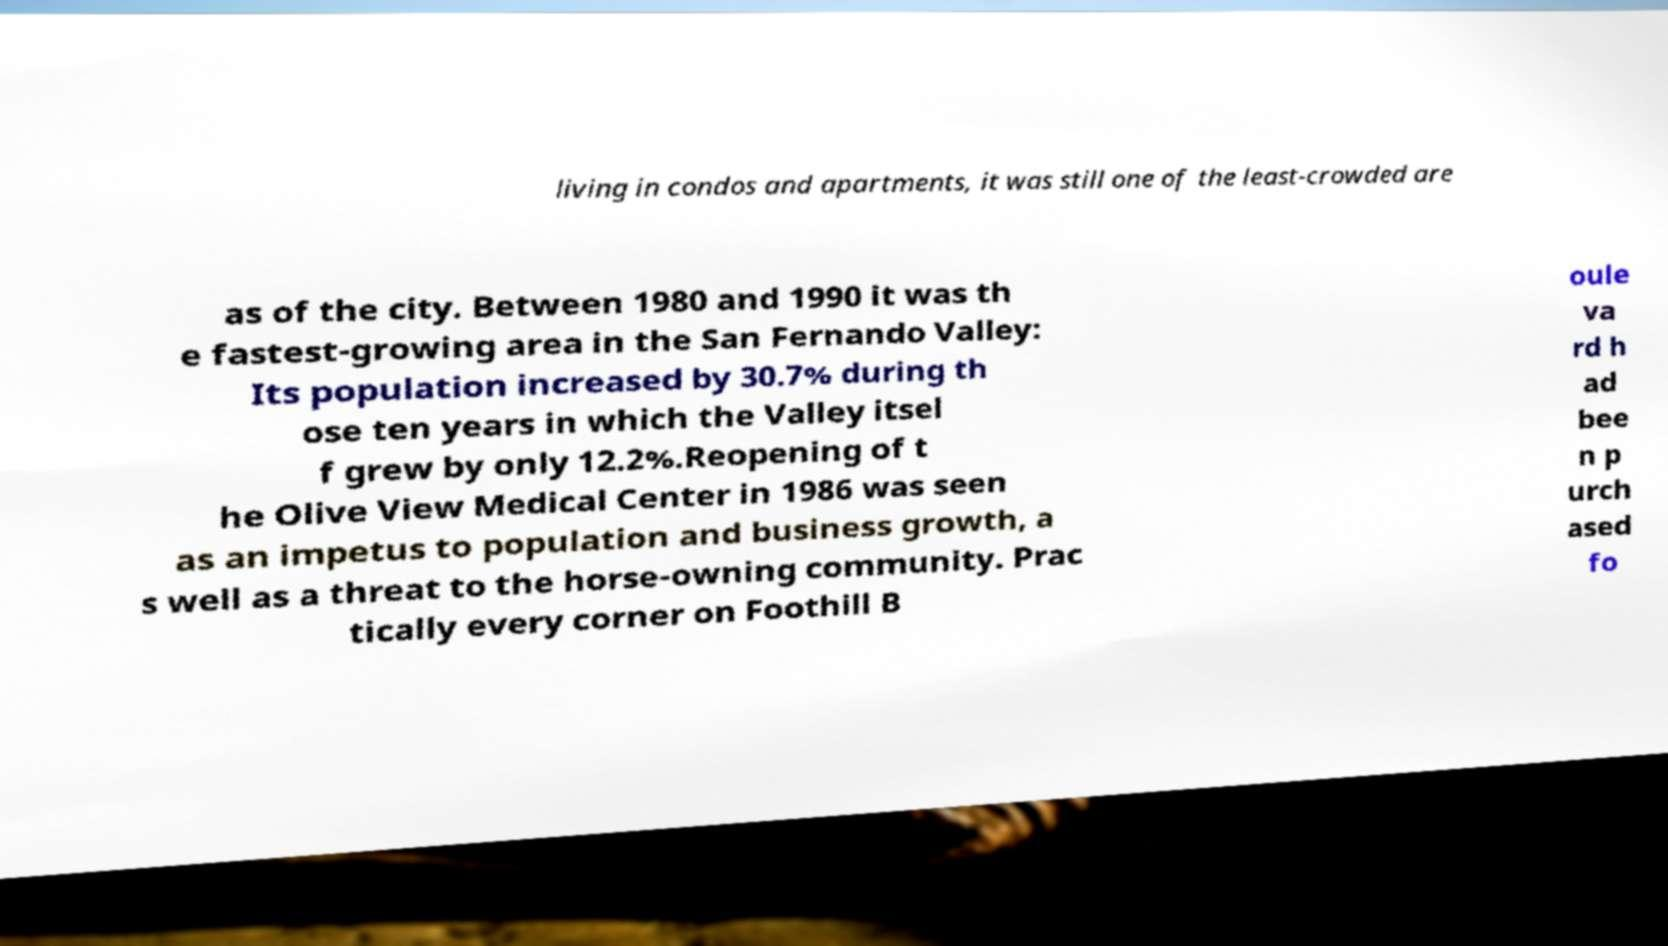There's text embedded in this image that I need extracted. Can you transcribe it verbatim? living in condos and apartments, it was still one of the least-crowded are as of the city. Between 1980 and 1990 it was th e fastest-growing area in the San Fernando Valley: Its population increased by 30.7% during th ose ten years in which the Valley itsel f grew by only 12.2%.Reopening of t he Olive View Medical Center in 1986 was seen as an impetus to population and business growth, a s well as a threat to the horse-owning community. Prac tically every corner on Foothill B oule va rd h ad bee n p urch ased fo 